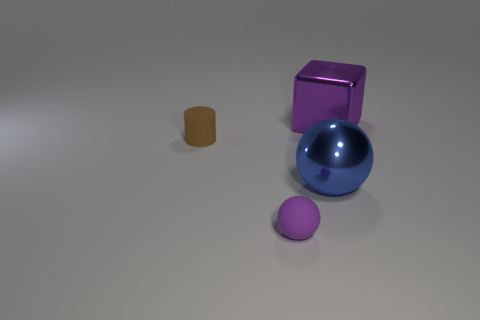Add 4 big blue rubber spheres. How many objects exist? 8 Subtract all cubes. How many objects are left? 3 Subtract all large objects. Subtract all yellow rubber objects. How many objects are left? 2 Add 1 blocks. How many blocks are left? 2 Add 4 small cyan shiny cylinders. How many small cyan shiny cylinders exist? 4 Subtract 0 yellow blocks. How many objects are left? 4 